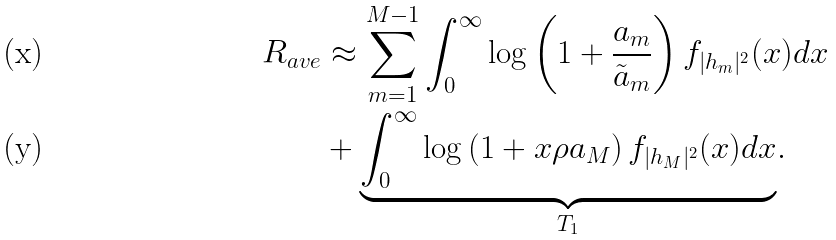<formula> <loc_0><loc_0><loc_500><loc_500>R _ { a v e } & \approx \sum ^ { M - 1 } _ { m = 1 } \int ^ { \infty } _ { 0 } \log \left ( 1 + \frac { a _ { m } } { \tilde { a } _ { m } } \right ) f _ { | h _ { m } | ^ { 2 } } ( x ) d x \\ & + \underset { T _ { 1 } } { \underbrace { \int ^ { \infty } _ { 0 } \log \left ( 1 + x \rho a _ { M } \right ) f _ { | h _ { M } | ^ { 2 } } ( x ) d x } } .</formula> 